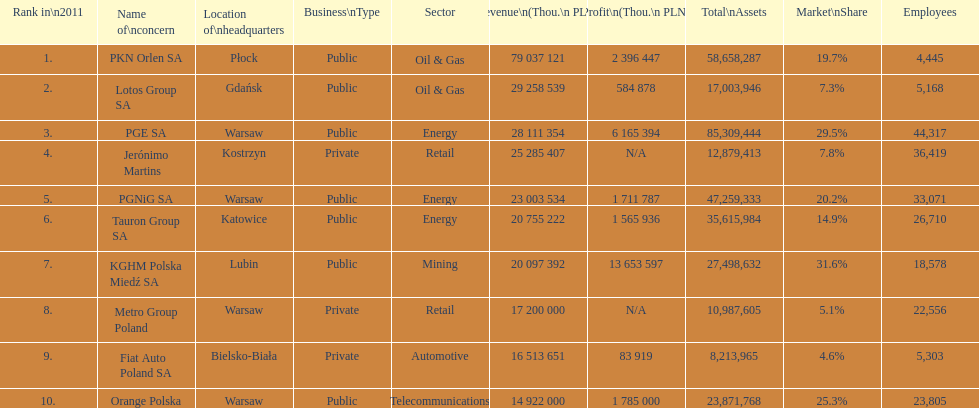At which company can the largest workforce be found? PGE SA. 